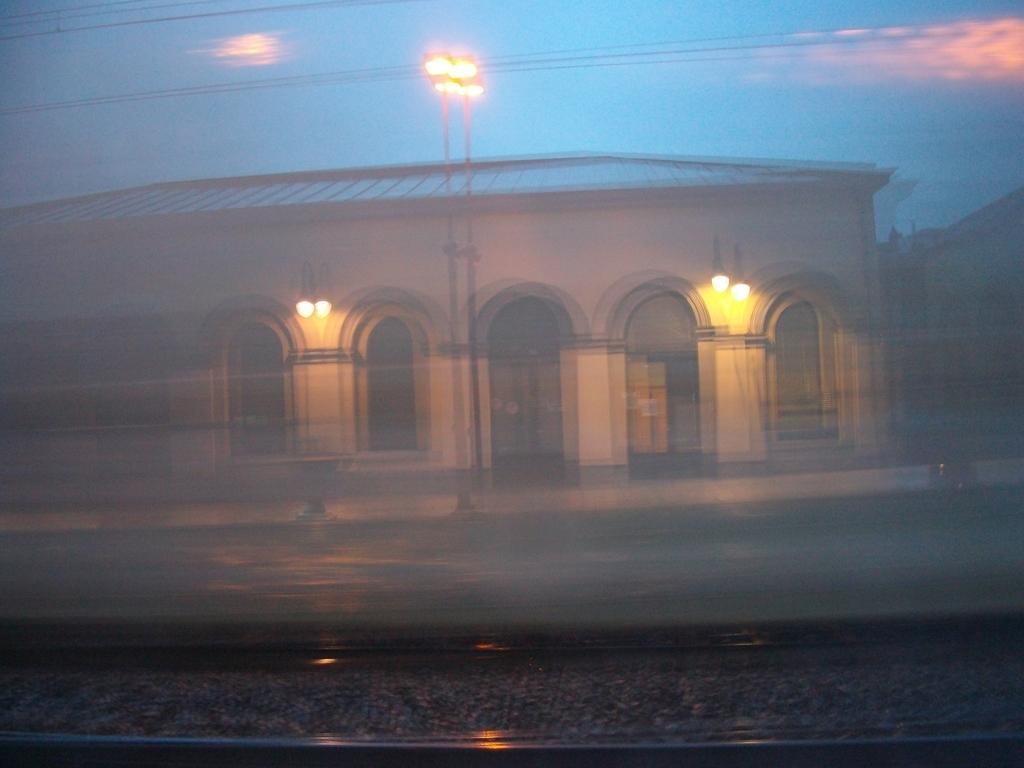Can you describe this image briefly? This is a blur image and it is clicked in the dark. At the bottom of the image I can see the railway track. In the background there is a building and a pole, on the top of it I can see a light. On the top of the image I can see the sky and wires. 